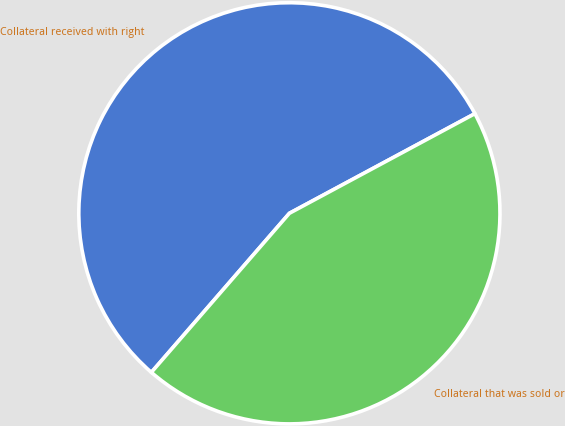<chart> <loc_0><loc_0><loc_500><loc_500><pie_chart><fcel>Collateral received with right<fcel>Collateral that was sold or<nl><fcel>55.78%<fcel>44.22%<nl></chart> 